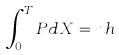Convert formula to latex. <formula><loc_0><loc_0><loc_500><loc_500>\int _ { 0 } ^ { T } P d X = n h</formula> 